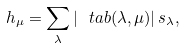<formula> <loc_0><loc_0><loc_500><loc_500>h _ { \mu } = \sum _ { \lambda } | \ t a b ( \lambda , \mu ) | \, s _ { \lambda } ,</formula> 